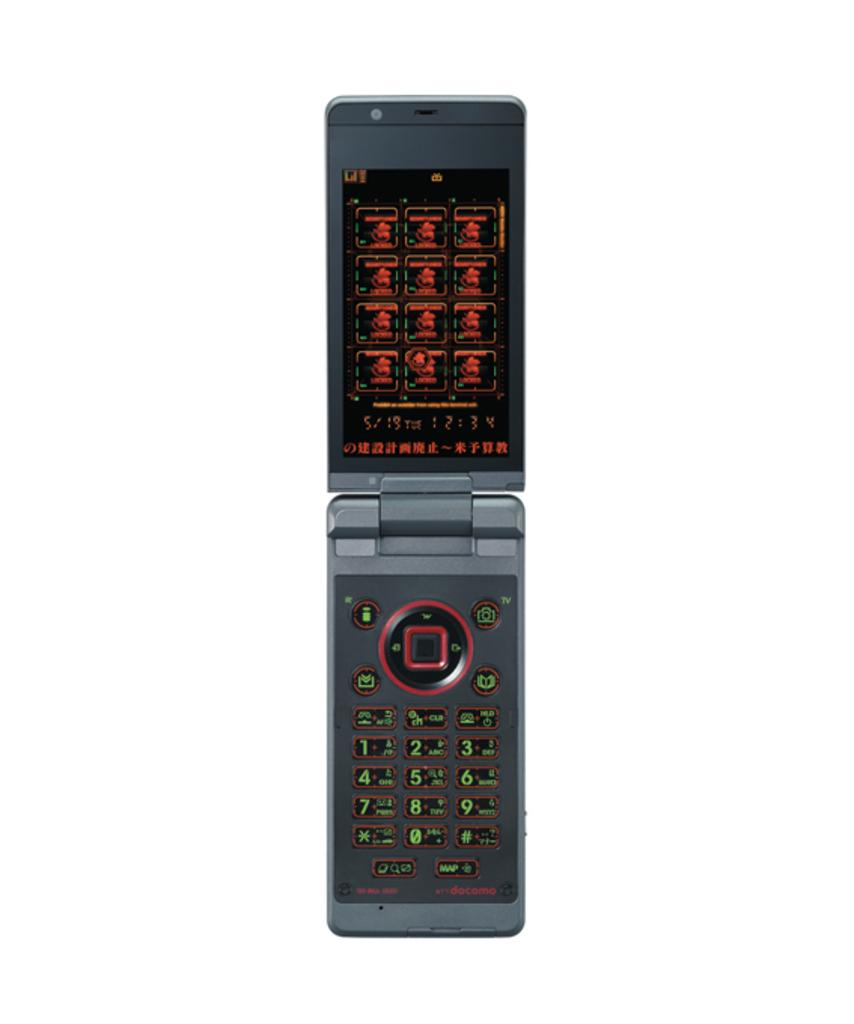<image>
Summarize the visual content of the image. The dial pad of a weird flip phone has a button labelled TV in the top right. 